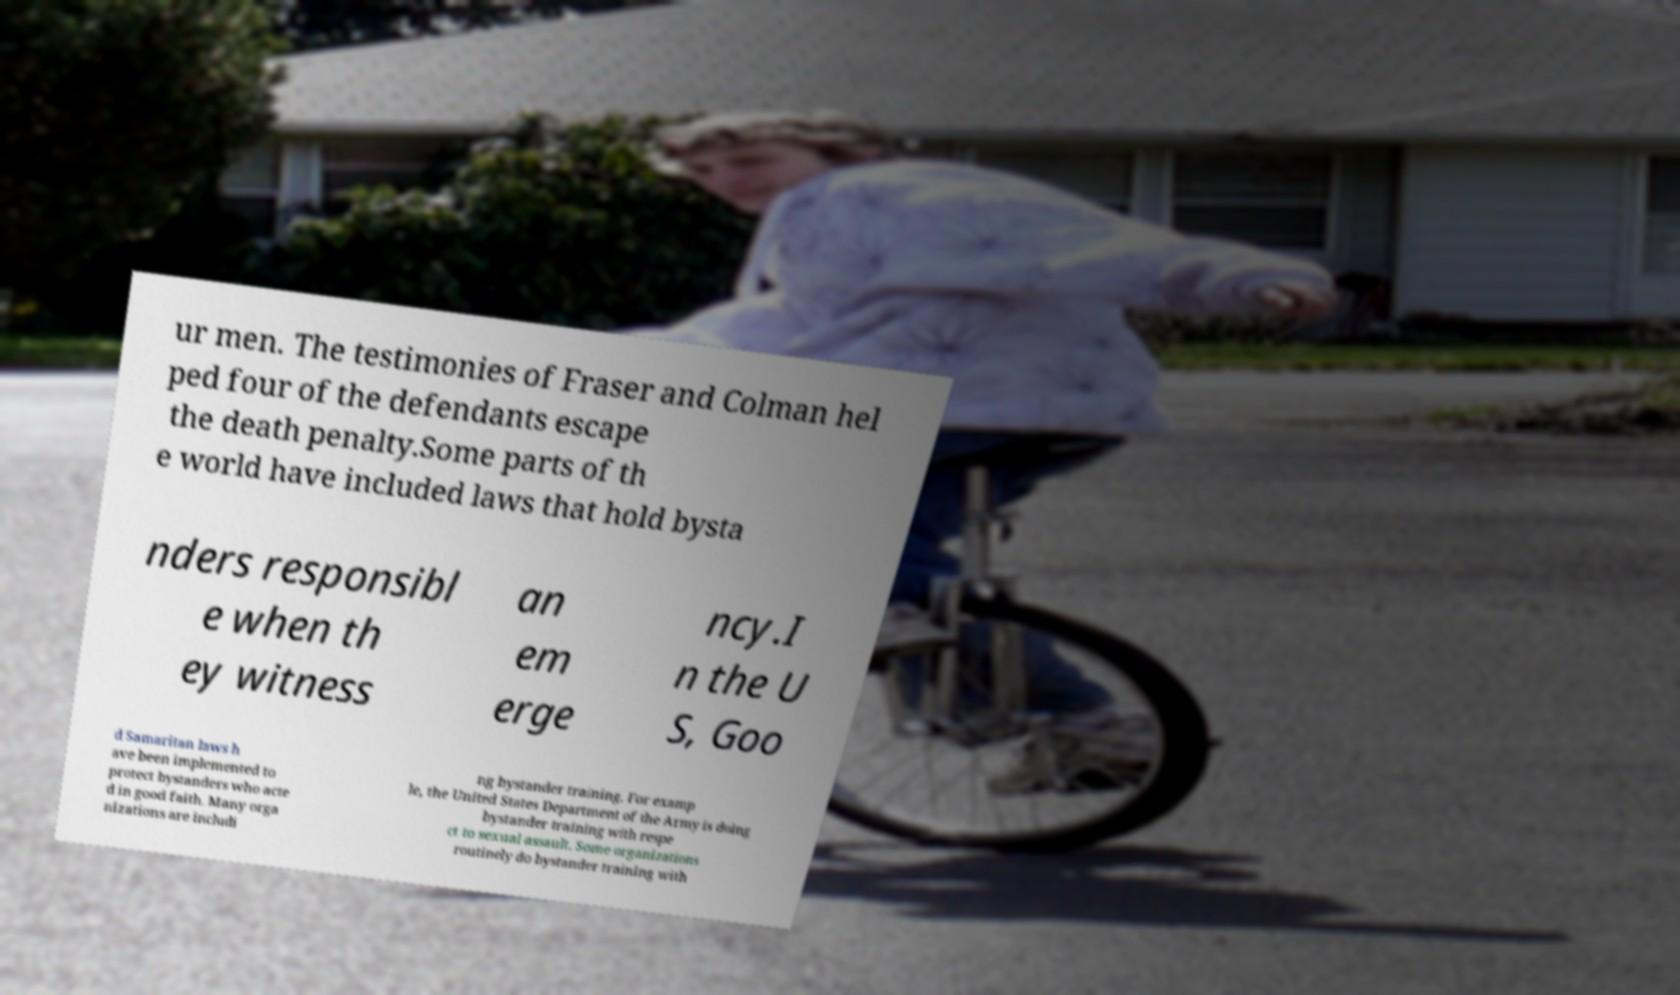For documentation purposes, I need the text within this image transcribed. Could you provide that? ur men. The testimonies of Fraser and Colman hel ped four of the defendants escape the death penalty.Some parts of th e world have included laws that hold bysta nders responsibl e when th ey witness an em erge ncy.I n the U S, Goo d Samaritan laws h ave been implemented to protect bystanders who acte d in good faith. Many orga nizations are includi ng bystander training. For examp le, the United States Department of the Army is doing bystander training with respe ct to sexual assault. Some organizations routinely do bystander training with 